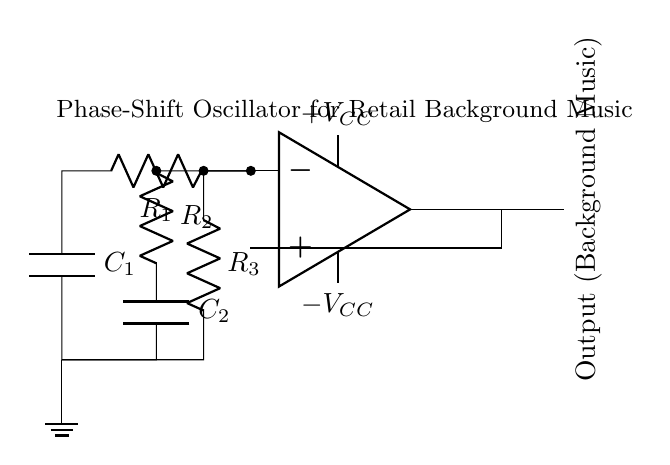What is the component type used to generate oscillation? The circuit uses an operational amplifier, which is a key component in oscillators for amplifying signals and generating oscillations.
Answer: Operational amplifier How many resistors are present in the circuit? The circuit includes three resistors labeled R1, R2, and R3, as clearly indicated in the diagram.
Answer: Three What is the purpose of capacitor C1 in the oscillator? Capacitor C1 is part of the RC network that helps in creating the phase shift necessary for the oscillation, thus contributing to the overall functionality of the oscillator.
Answer: Phase shift What configuration is used to connect the output of the op-amp? The output of the op-amp is connected to a feedback loop, which is essential for sustaining oscillations by providing positive feedback.
Answer: Feedback loop What type of oscillator is represented in this diagram? The circuit is a phase-shift oscillator, which specifically utilizes multiple RC stages to achieve the required phase shift for oscillation.
Answer: Phase-shift oscillator What is the significance of the ground connection in the circuit? The ground connection serves as a reference point for voltage and ensures stability in the circuit, which is crucial for proper operation of the oscillator.
Answer: Reference point 